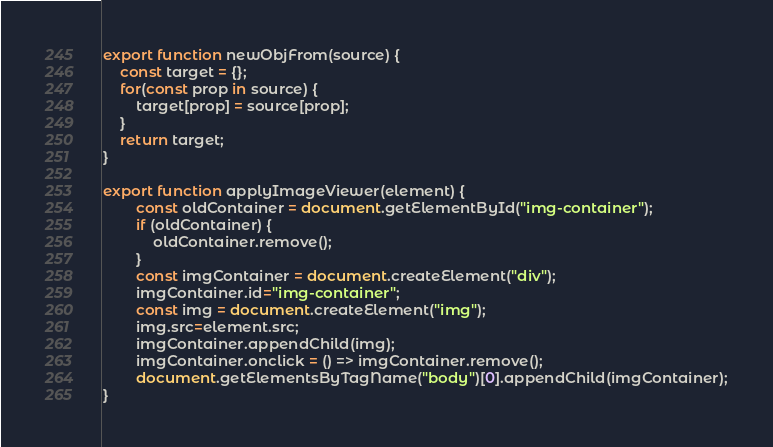<code> <loc_0><loc_0><loc_500><loc_500><_JavaScript_>export function newObjFrom(source) {
    const target = {};
    for(const prop in source) {
        target[prop] = source[prop];
    }
    return target;
}

export function applyImageViewer(element) {
        const oldContainer = document.getElementById("img-container");
        if (oldContainer) {
            oldContainer.remove();
        }
        const imgContainer = document.createElement("div");
        imgContainer.id="img-container";
        const img = document.createElement("img");
        img.src=element.src;
        imgContainer.appendChild(img);
        imgContainer.onclick = () => imgContainer.remove();
        document.getElementsByTagName("body")[0].appendChild(imgContainer);
}</code> 